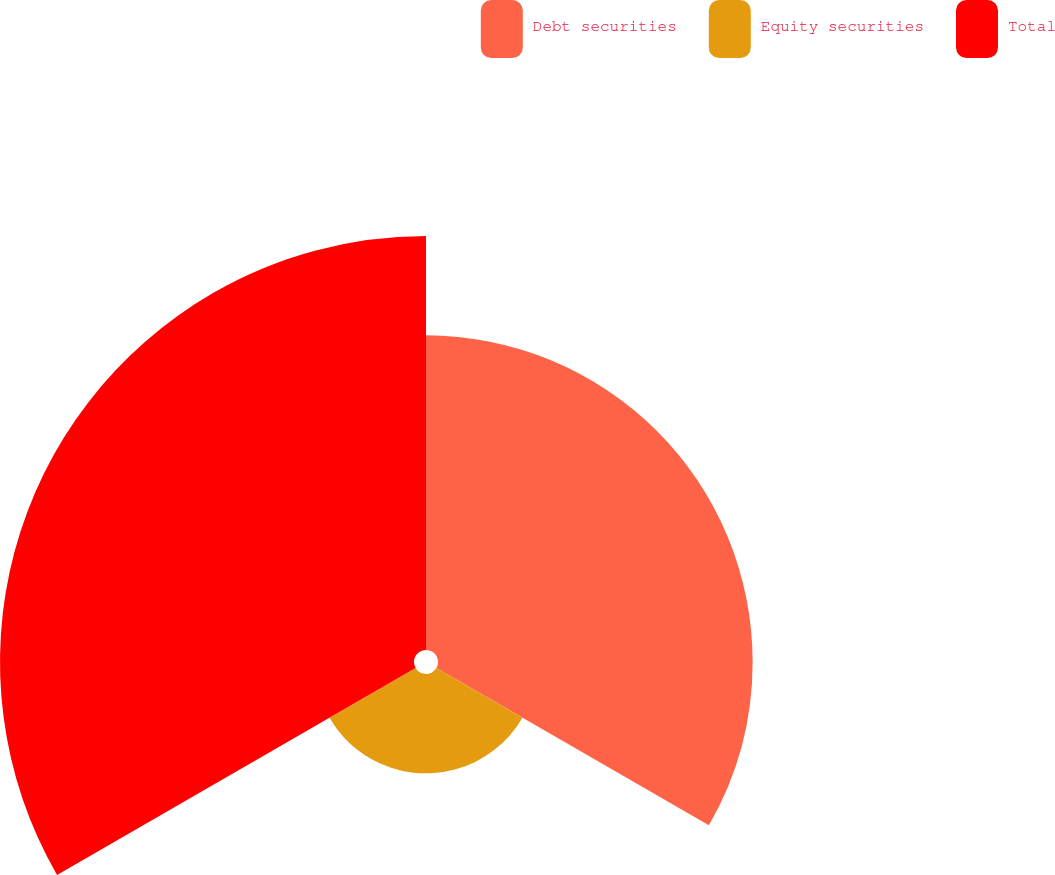<chart> <loc_0><loc_0><loc_500><loc_500><pie_chart><fcel>Debt securities<fcel>Equity securities<fcel>Total<nl><fcel>38.0%<fcel>12.0%<fcel>50.0%<nl></chart> 